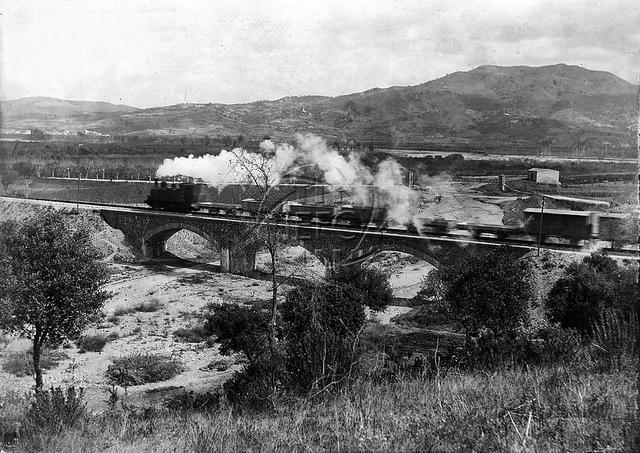How many trains are visible?
Give a very brief answer. 1. 